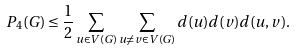<formula> <loc_0><loc_0><loc_500><loc_500>P _ { 4 } ( G ) \leq \frac { 1 } { 2 } \sum _ { u \in V ( G ) } \sum _ { u \neq v \in V ( G ) } d ( u ) d ( v ) d ( u , v ) .</formula> 